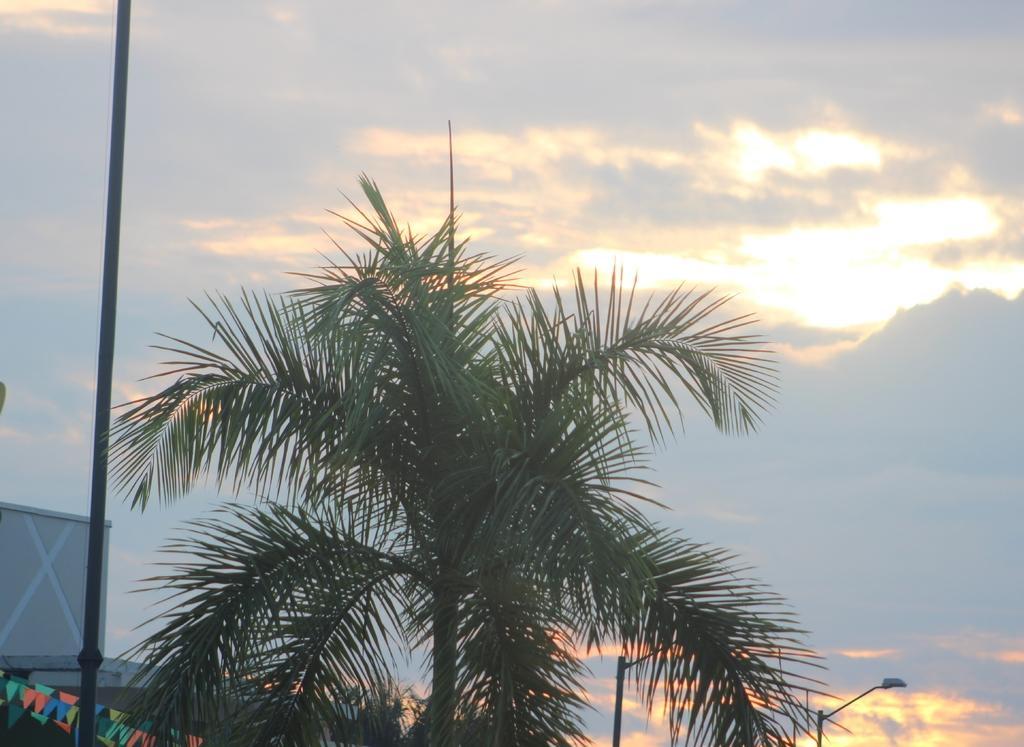What is the main subject in the center of the image? There is a tree in the center of the image. What structures can be seen in the image? Electric light poles are present in the image. What decorative items are visible in the image? Flags are visible in the image. What architectural feature is present in the image? There is a wall in the image. What can be seen in the sky at the top of the image? Clouds are present in the sky at the top of the image. What type of cream is being used to punish the person in the image? There is no person or punishment present in the image; it features a tree, electric light poles, flags, a wall, and clouds in the sky. 